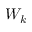Convert formula to latex. <formula><loc_0><loc_0><loc_500><loc_500>W _ { k }</formula> 